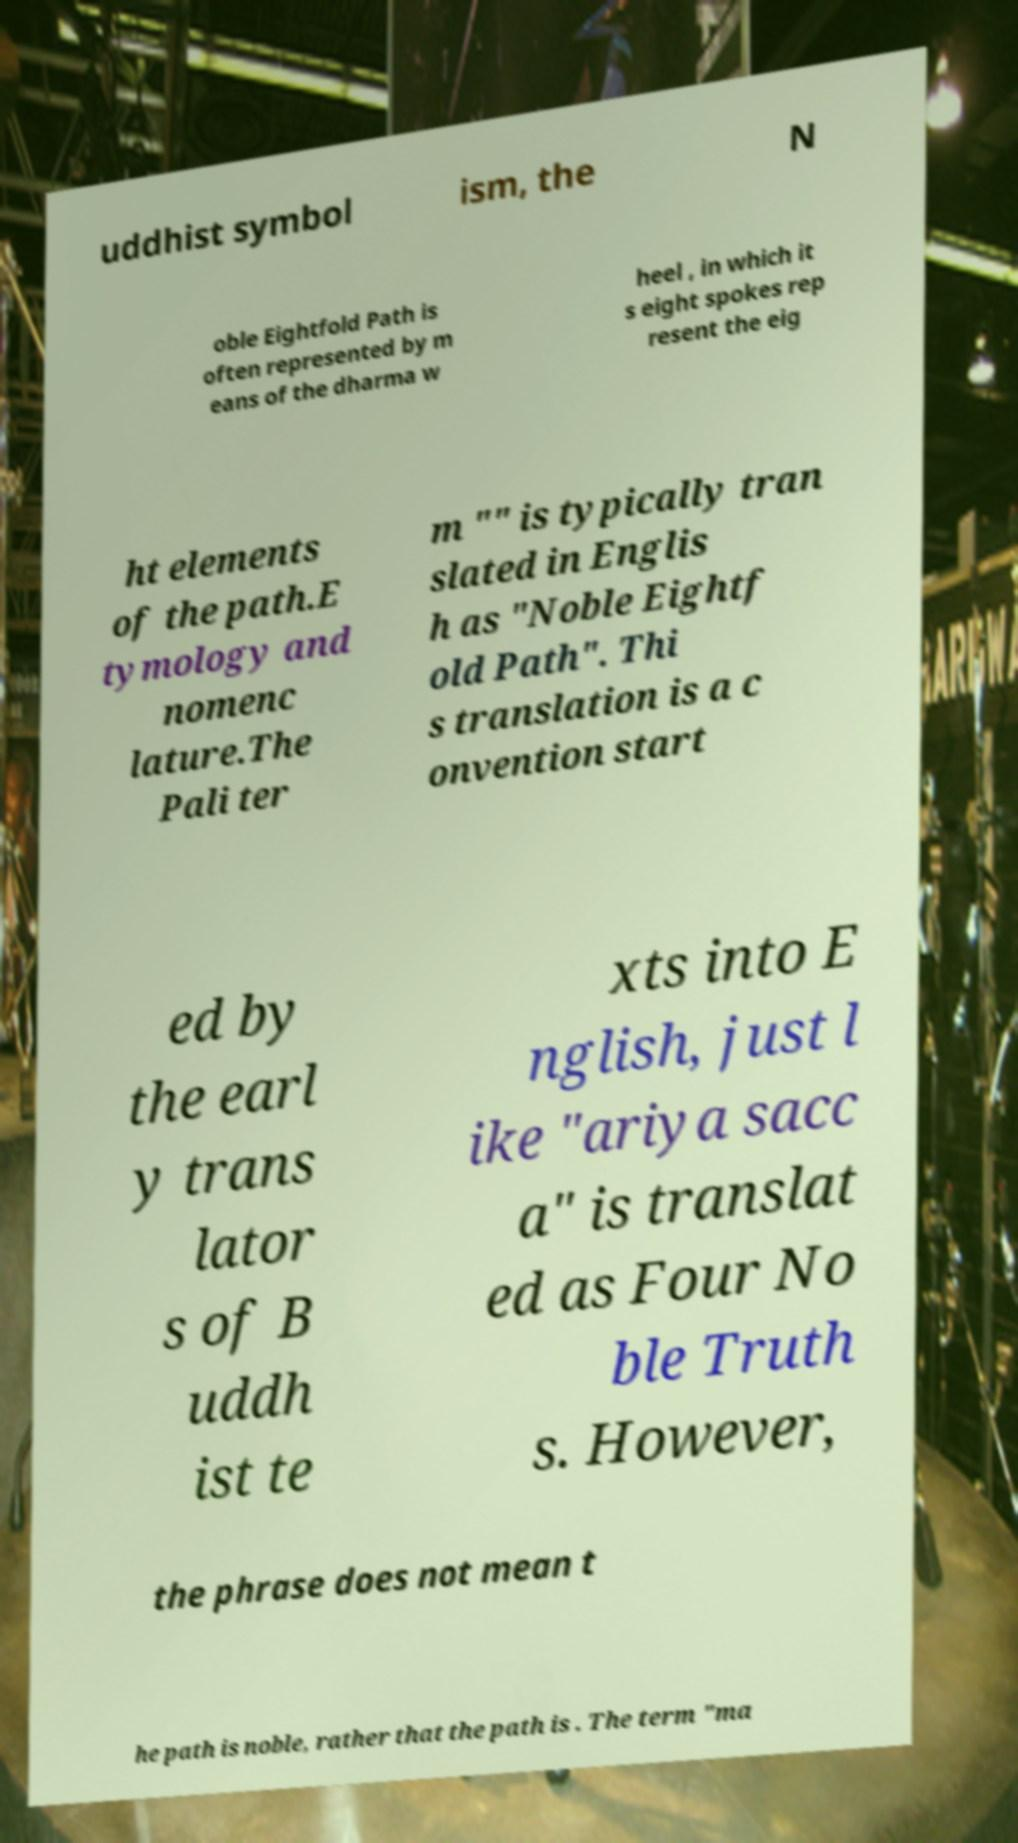For documentation purposes, I need the text within this image transcribed. Could you provide that? uddhist symbol ism, the N oble Eightfold Path is often represented by m eans of the dharma w heel , in which it s eight spokes rep resent the eig ht elements of the path.E tymology and nomenc lature.The Pali ter m "" is typically tran slated in Englis h as "Noble Eightf old Path". Thi s translation is a c onvention start ed by the earl y trans lator s of B uddh ist te xts into E nglish, just l ike "ariya sacc a" is translat ed as Four No ble Truth s. However, the phrase does not mean t he path is noble, rather that the path is . The term "ma 